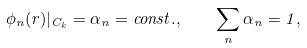Convert formula to latex. <formula><loc_0><loc_0><loc_500><loc_500>\phi _ { n } ( { r } ) | _ { C _ { k } } = \alpha _ { n } = c o n s t . , \quad \sum _ { n } \alpha _ { n } = 1 ,</formula> 